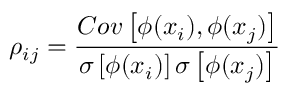<formula> <loc_0><loc_0><loc_500><loc_500>\rho _ { i j } = \frac { C o v \left [ \phi ( x _ { i } ) , \phi ( x _ { j } ) \right ] } { \sigma \left [ \phi ( x _ { i } ) \right ] \sigma \left [ \phi ( x _ { j } ) \right ] }</formula> 